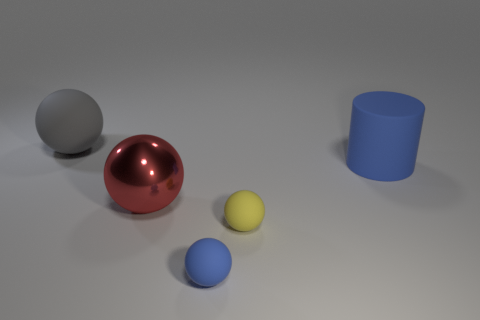Does the matte cylinder have the same color as the big metallic ball?
Your answer should be compact. No. Is the number of gray rubber things that are right of the big red metallic sphere greater than the number of large rubber spheres?
Keep it short and to the point. No. How many other objects are the same material as the small blue sphere?
Your answer should be very brief. 3. What number of large things are gray rubber objects or shiny things?
Offer a terse response. 2. Is the cylinder made of the same material as the gray ball?
Ensure brevity in your answer.  Yes. What number of large rubber things are on the left side of the large thing in front of the blue matte cylinder?
Offer a very short reply. 1. Are there any other red objects of the same shape as the big metallic object?
Give a very brief answer. No. Do the large matte thing that is on the left side of the rubber cylinder and the big thing that is to the right of the large red thing have the same shape?
Make the answer very short. No. There is a thing that is both behind the large red ball and in front of the large gray thing; what shape is it?
Keep it short and to the point. Cylinder. Are there any other cylinders of the same size as the rubber cylinder?
Ensure brevity in your answer.  No. 